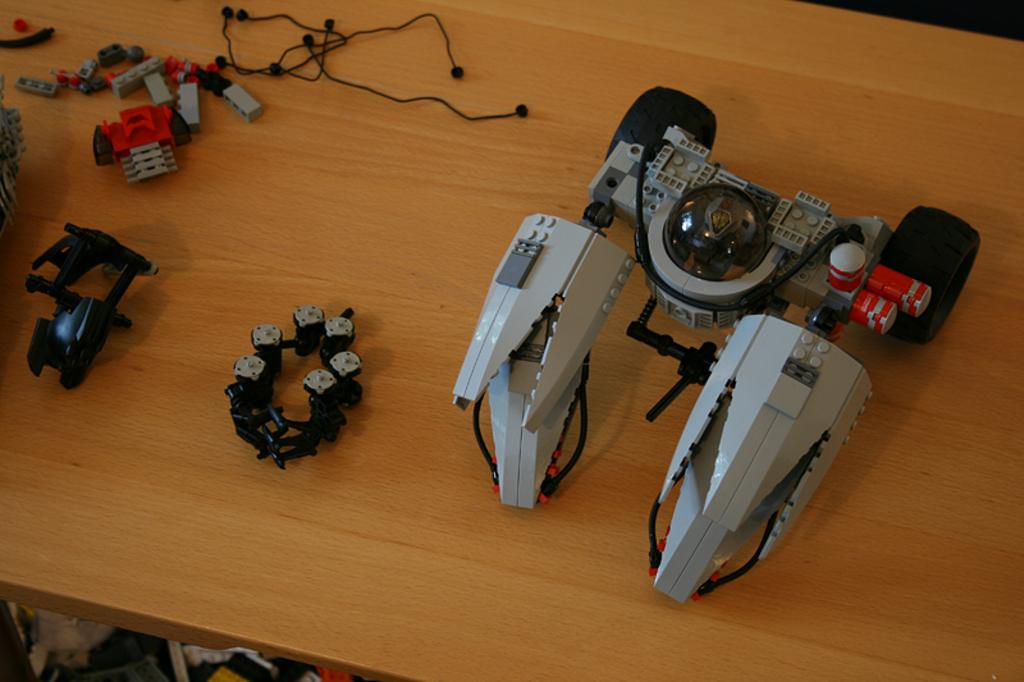What type of furniture is present in the image? There is a table in the image. What is placed on the table? There are electrical equipment on the table. How many snails can be seen crawling on the elbow in the image? There is no elbow or snails present in the image. 